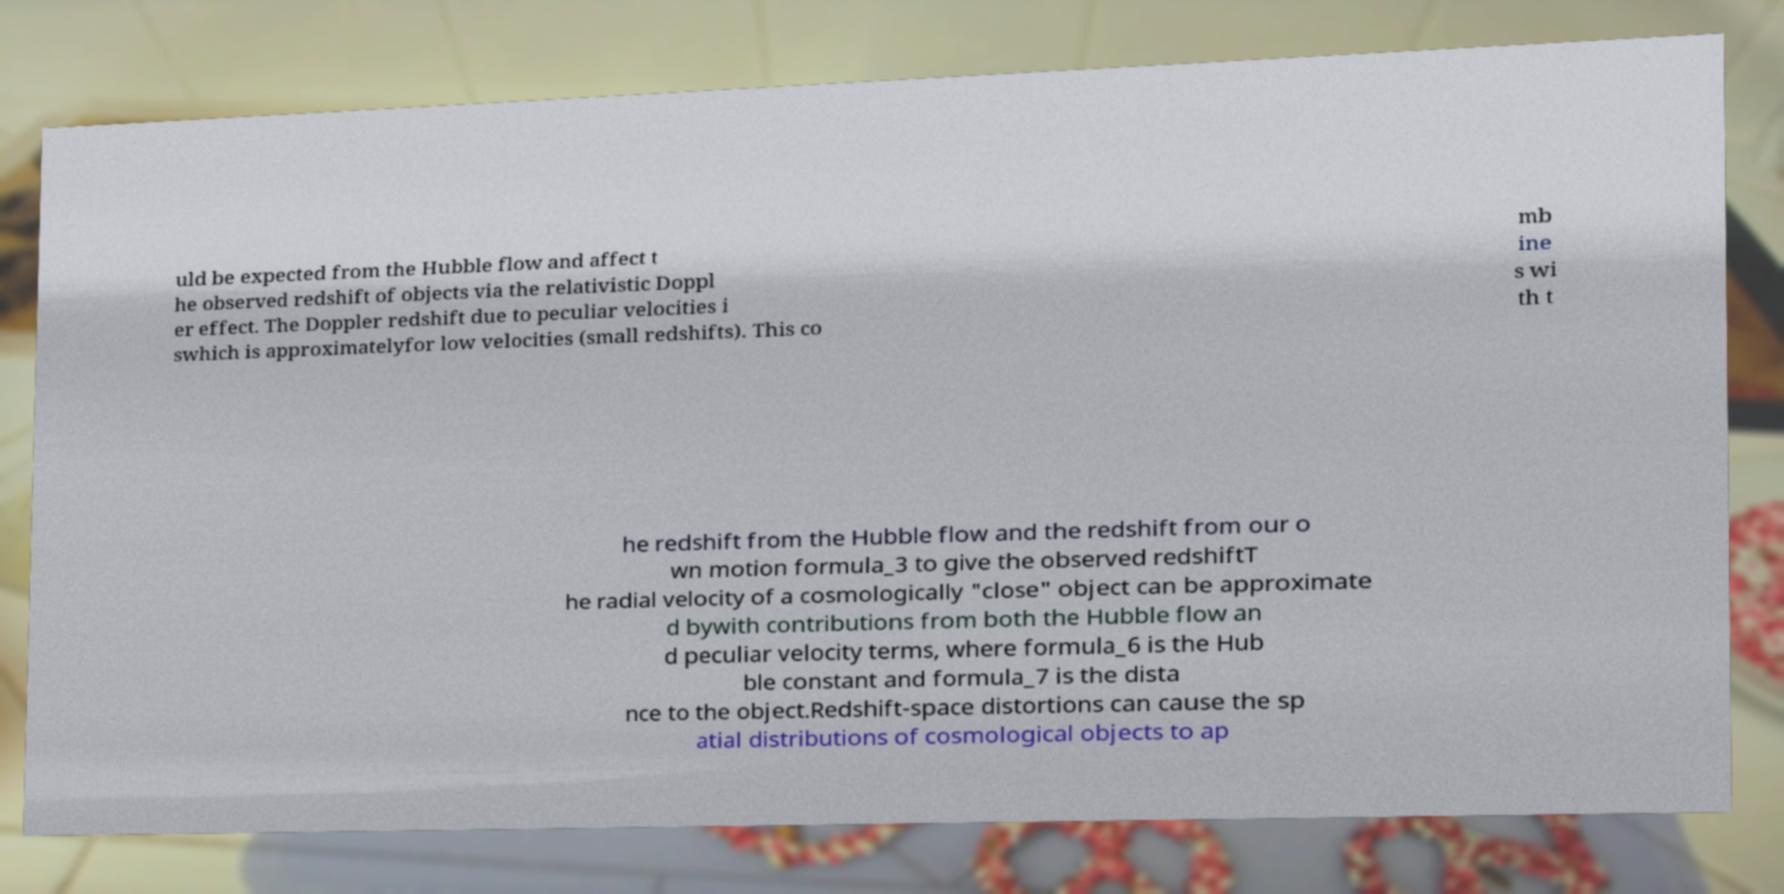Could you extract and type out the text from this image? uld be expected from the Hubble flow and affect t he observed redshift of objects via the relativistic Doppl er effect. The Doppler redshift due to peculiar velocities i swhich is approximatelyfor low velocities (small redshifts). This co mb ine s wi th t he redshift from the Hubble flow and the redshift from our o wn motion formula_3 to give the observed redshiftT he radial velocity of a cosmologically "close" object can be approximate d bywith contributions from both the Hubble flow an d peculiar velocity terms, where formula_6 is the Hub ble constant and formula_7 is the dista nce to the object.Redshift-space distortions can cause the sp atial distributions of cosmological objects to ap 